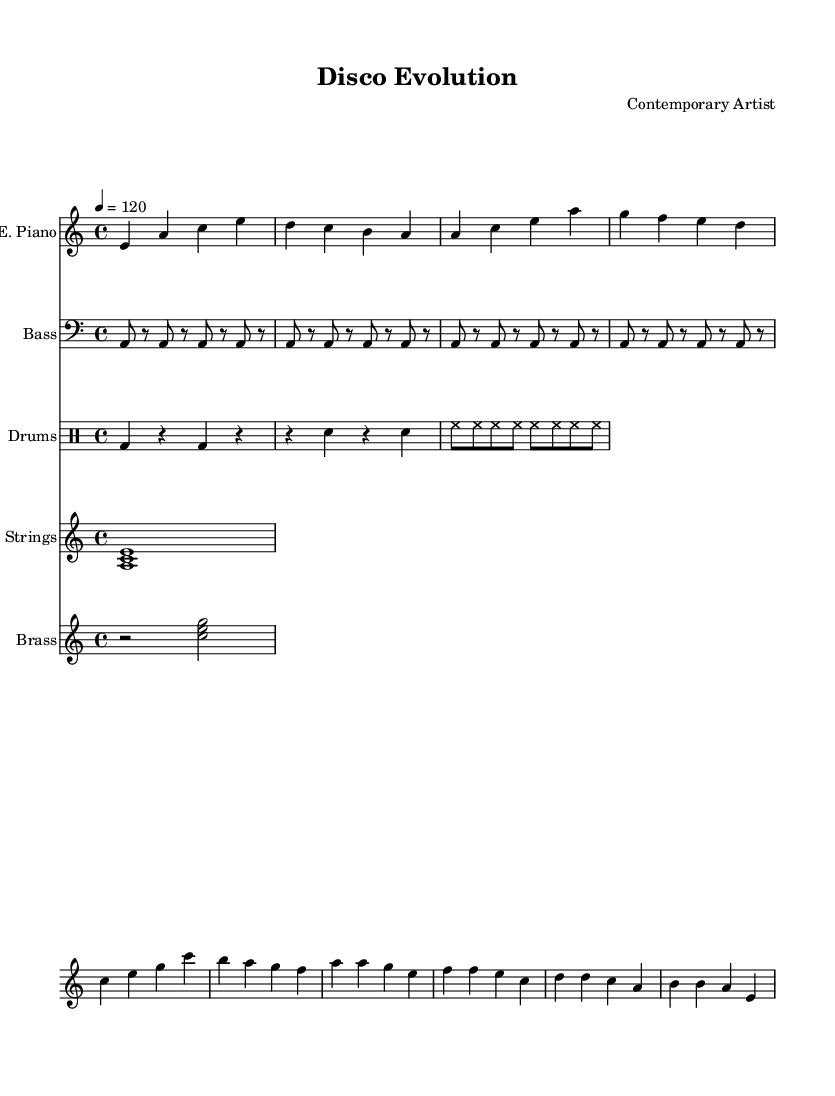What is the key signature of this music? The key signature can be found at the beginning of the piece, showing one flat, which indicates A minor.
Answer: A minor What is the time signature of this music? The time signature is located at the beginning and is expressed as 4/4, indicating four beats per measure.
Answer: 4/4 What is the tempo marking? The tempo marking indicates a speed of 120 beats per minute, as denoted in the score using the word "tempo."
Answer: 120 How many measures are in the E. Piano part? To find the number of measures, one would count each vertical line that divides the music into segments, which total 8 measures in the E. Piano part.
Answer: 8 What instruments are present in the score? The instruments can be identified by their names listed at the beginning of each staff; they include Electric Piano, Bass, Drums, Strings, and Brass.
Answer: Electric Piano, Bass, Drums, Strings, Brass In what musical style is this piece composed? The specific elements influencing the answer are the rhythms, melodies, and instrument selection typical of disco music, which prominently features danceable grooves and synthesizers.
Answer: Disco Which staff features the bass guitar notated? The bass guitar is indicated on the second staff from the top of the score, clearly labeled as “Bass.”
Answer: Bass 